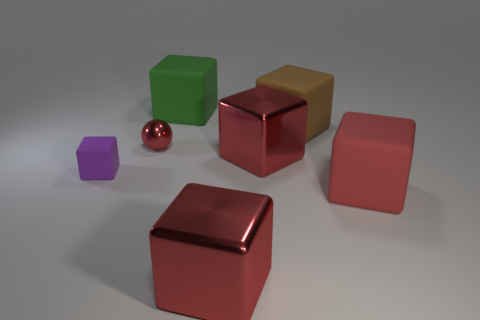What number of red objects are either things or rubber cylinders?
Offer a terse response. 4. Are there any green rubber blocks that have the same size as the brown block?
Your answer should be compact. Yes. There is a brown object that is the same size as the green rubber block; what material is it?
Keep it short and to the point. Rubber. Does the red object to the left of the big green cube have the same size as the red rubber cube right of the small purple rubber thing?
Your answer should be compact. No. What number of things are either tiny cyan matte cylinders or large red metal blocks that are in front of the tiny rubber block?
Offer a terse response. 1. Is there a tiny red rubber object of the same shape as the big brown rubber object?
Your response must be concise. No. There is a rubber block to the left of the red metal thing left of the green object; what is its size?
Keep it short and to the point. Small. What number of metal objects are tiny purple things or green cubes?
Provide a succinct answer. 0. How many matte blocks are there?
Provide a succinct answer. 4. Do the small thing in front of the small sphere and the red cube that is behind the small rubber thing have the same material?
Your answer should be very brief. No. 